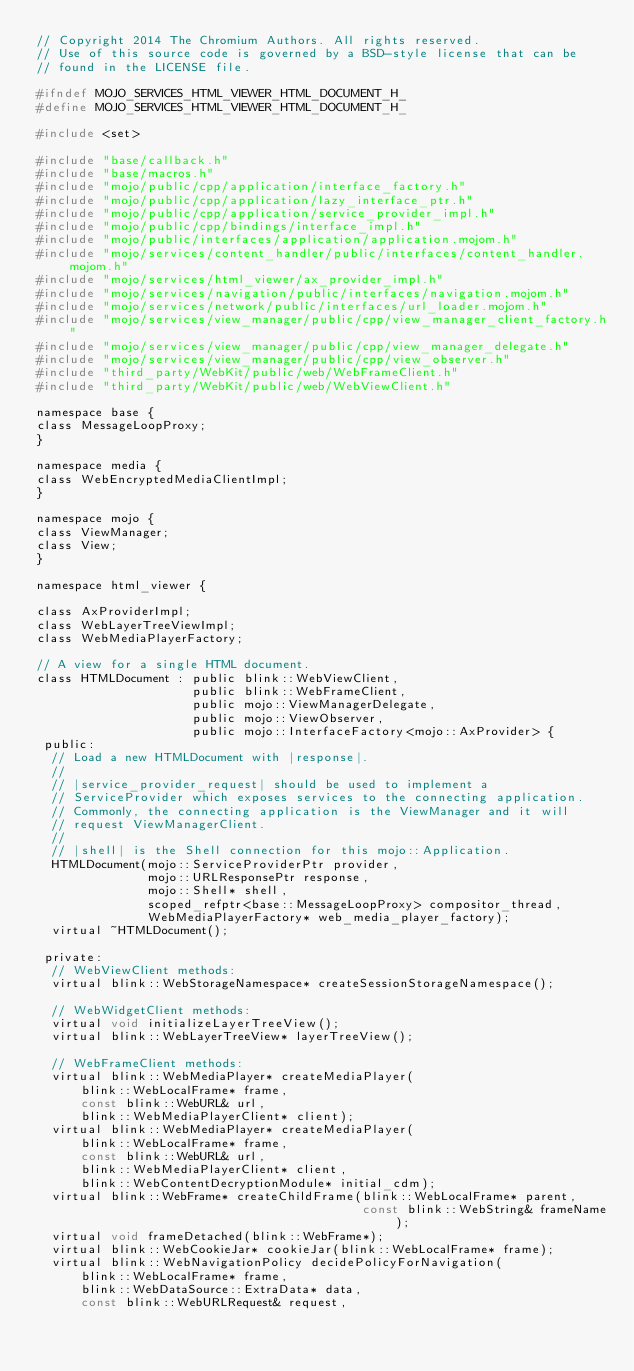<code> <loc_0><loc_0><loc_500><loc_500><_C_>// Copyright 2014 The Chromium Authors. All rights reserved.
// Use of this source code is governed by a BSD-style license that can be
// found in the LICENSE file.

#ifndef MOJO_SERVICES_HTML_VIEWER_HTML_DOCUMENT_H_
#define MOJO_SERVICES_HTML_VIEWER_HTML_DOCUMENT_H_

#include <set>

#include "base/callback.h"
#include "base/macros.h"
#include "mojo/public/cpp/application/interface_factory.h"
#include "mojo/public/cpp/application/lazy_interface_ptr.h"
#include "mojo/public/cpp/application/service_provider_impl.h"
#include "mojo/public/cpp/bindings/interface_impl.h"
#include "mojo/public/interfaces/application/application.mojom.h"
#include "mojo/services/content_handler/public/interfaces/content_handler.mojom.h"
#include "mojo/services/html_viewer/ax_provider_impl.h"
#include "mojo/services/navigation/public/interfaces/navigation.mojom.h"
#include "mojo/services/network/public/interfaces/url_loader.mojom.h"
#include "mojo/services/view_manager/public/cpp/view_manager_client_factory.h"
#include "mojo/services/view_manager/public/cpp/view_manager_delegate.h"
#include "mojo/services/view_manager/public/cpp/view_observer.h"
#include "third_party/WebKit/public/web/WebFrameClient.h"
#include "third_party/WebKit/public/web/WebViewClient.h"

namespace base {
class MessageLoopProxy;
}

namespace media {
class WebEncryptedMediaClientImpl;
}

namespace mojo {
class ViewManager;
class View;
}

namespace html_viewer {

class AxProviderImpl;
class WebLayerTreeViewImpl;
class WebMediaPlayerFactory;

// A view for a single HTML document.
class HTMLDocument : public blink::WebViewClient,
                     public blink::WebFrameClient,
                     public mojo::ViewManagerDelegate,
                     public mojo::ViewObserver,
                     public mojo::InterfaceFactory<mojo::AxProvider> {
 public:
  // Load a new HTMLDocument with |response|.
  //
  // |service_provider_request| should be used to implement a
  // ServiceProvider which exposes services to the connecting application.
  // Commonly, the connecting application is the ViewManager and it will
  // request ViewManagerClient.
  //
  // |shell| is the Shell connection for this mojo::Application.
  HTMLDocument(mojo::ServiceProviderPtr provider,
               mojo::URLResponsePtr response,
               mojo::Shell* shell,
               scoped_refptr<base::MessageLoopProxy> compositor_thread,
               WebMediaPlayerFactory* web_media_player_factory);
  virtual ~HTMLDocument();

 private:
  // WebViewClient methods:
  virtual blink::WebStorageNamespace* createSessionStorageNamespace();

  // WebWidgetClient methods:
  virtual void initializeLayerTreeView();
  virtual blink::WebLayerTreeView* layerTreeView();

  // WebFrameClient methods:
  virtual blink::WebMediaPlayer* createMediaPlayer(
      blink::WebLocalFrame* frame,
      const blink::WebURL& url,
      blink::WebMediaPlayerClient* client);
  virtual blink::WebMediaPlayer* createMediaPlayer(
      blink::WebLocalFrame* frame,
      const blink::WebURL& url,
      blink::WebMediaPlayerClient* client,
      blink::WebContentDecryptionModule* initial_cdm);
  virtual blink::WebFrame* createChildFrame(blink::WebLocalFrame* parent,
                                            const blink::WebString& frameName);
  virtual void frameDetached(blink::WebFrame*);
  virtual blink::WebCookieJar* cookieJar(blink::WebLocalFrame* frame);
  virtual blink::WebNavigationPolicy decidePolicyForNavigation(
      blink::WebLocalFrame* frame,
      blink::WebDataSource::ExtraData* data,
      const blink::WebURLRequest& request,</code> 